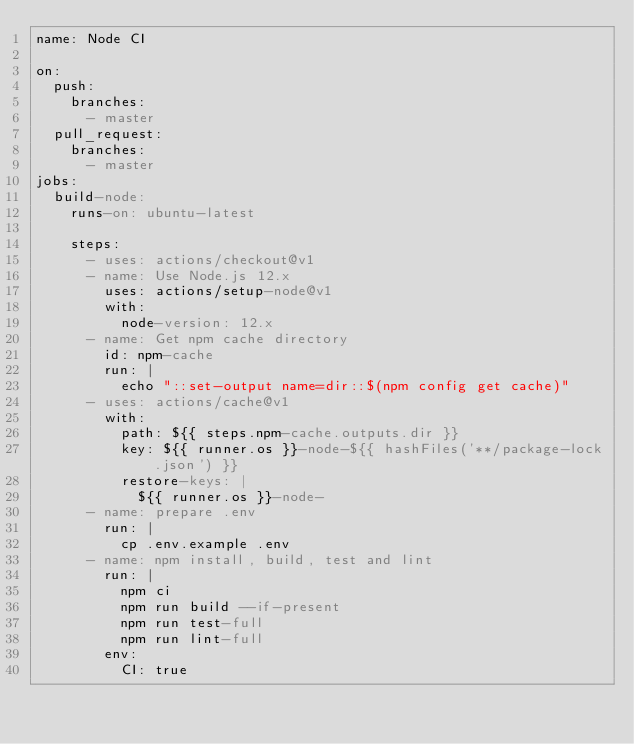<code> <loc_0><loc_0><loc_500><loc_500><_YAML_>name: Node CI

on:
  push:
    branches:
      - master
  pull_request:
    branches:
      - master
jobs:
  build-node:
    runs-on: ubuntu-latest

    steps:
      - uses: actions/checkout@v1
      - name: Use Node.js 12.x
        uses: actions/setup-node@v1
        with:
          node-version: 12.x
      - name: Get npm cache directory
        id: npm-cache
        run: |
          echo "::set-output name=dir::$(npm config get cache)"
      - uses: actions/cache@v1
        with:
          path: ${{ steps.npm-cache.outputs.dir }}
          key: ${{ runner.os }}-node-${{ hashFiles('**/package-lock.json') }}
          restore-keys: |
            ${{ runner.os }}-node-
      - name: prepare .env
        run: |
          cp .env.example .env
      - name: npm install, build, test and lint
        run: |
          npm ci
          npm run build --if-present
          npm run test-full
          npm run lint-full
        env:
          CI: true
</code> 